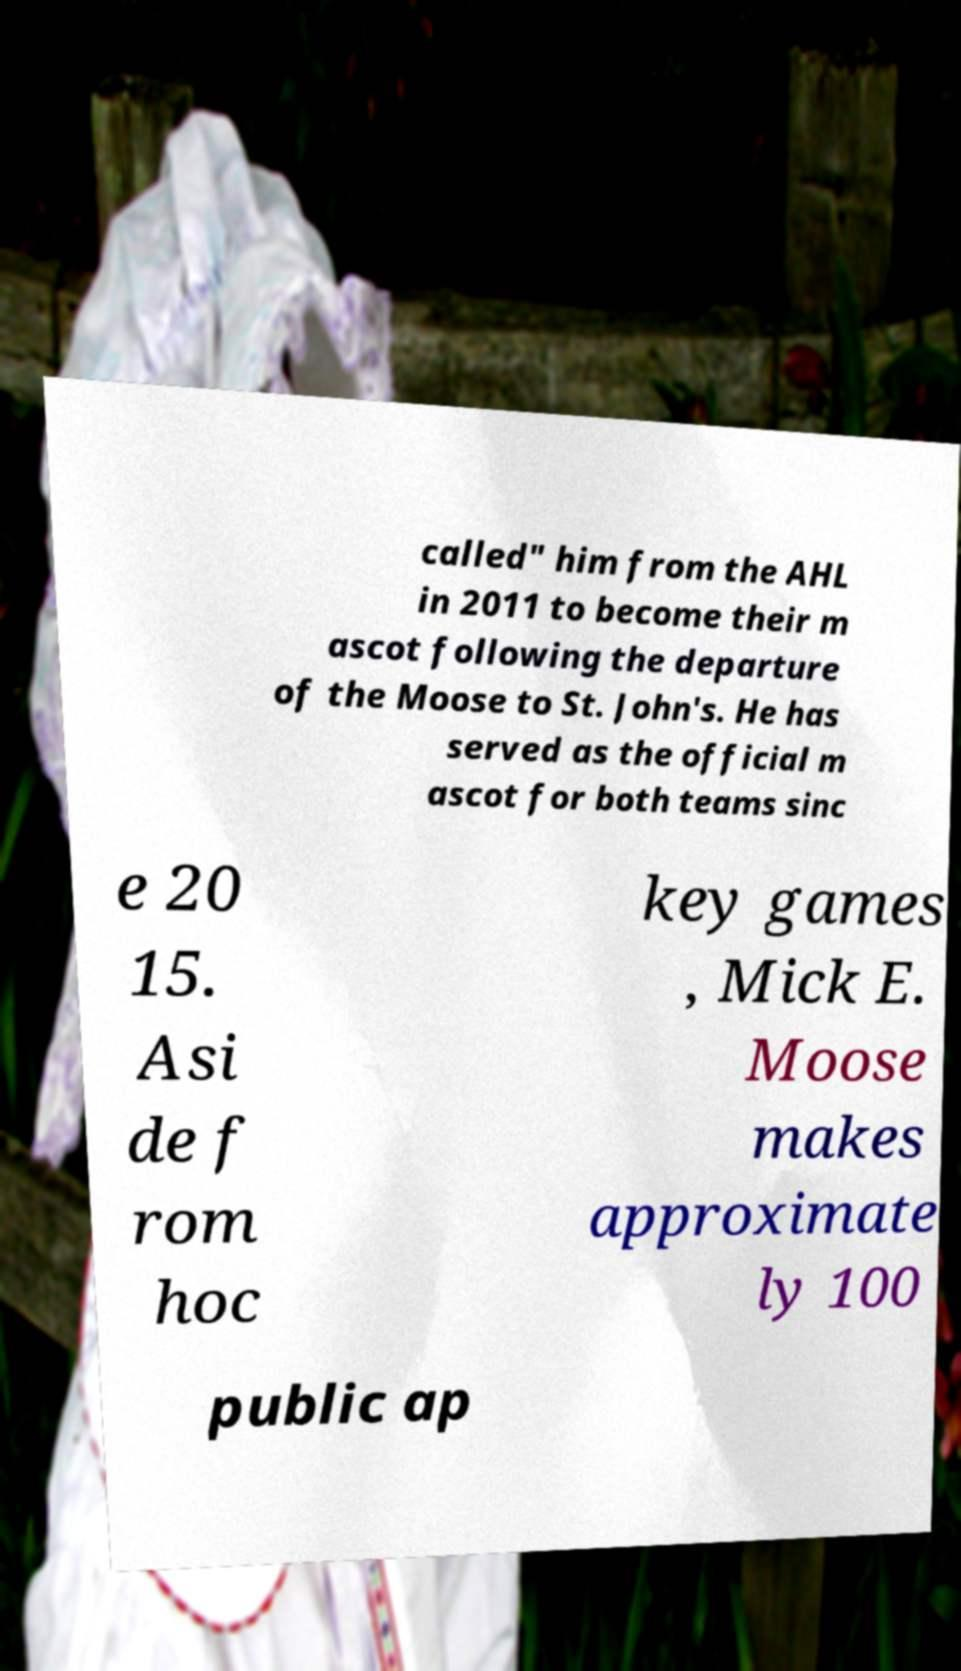I need the written content from this picture converted into text. Can you do that? called" him from the AHL in 2011 to become their m ascot following the departure of the Moose to St. John's. He has served as the official m ascot for both teams sinc e 20 15. Asi de f rom hoc key games , Mick E. Moose makes approximate ly 100 public ap 